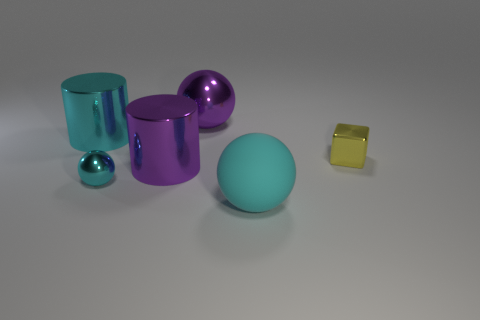Which object in the image is the smallest, and what color is it? The smallest object in the image is the sphere which has a reflective chrome color. It seems to be lying closest to the viewer at the bottom portion of the image. 